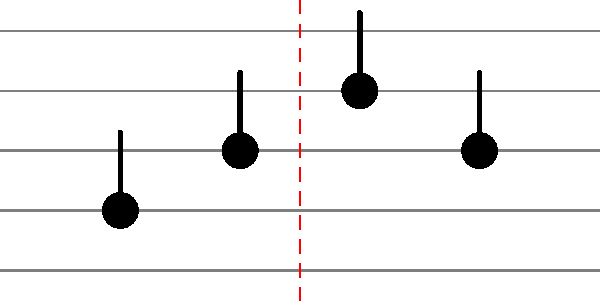In this musical notation pattern inspired by Dardust's compositions, what type of symmetry is exhibited by the arrangement of notes? To determine the type of symmetry in this musical notation pattern, let's analyze it step-by-step:

1. Observe the arrangement of notes on the staff:
   - The first note is on the second line from the bottom.
   - The second note is in the space between the second and third lines.
   - The third note is on the third line.
   - The fourth note is in the space between the second and third lines.

2. Notice the red dashed line in the middle of the staff. This line acts as a potential axis of symmetry.

3. Compare the notes on either side of the red dashed line:
   - The first and fourth notes are equidistant from the red line.
   - The second and third notes are also equidistant from the red line.

4. Imagine folding the staff along the red dashed line:
   - The first note would overlap with the fourth note.
   - The second note would overlap with the third note.

5. This pattern of reflection around a central axis is characteristic of reflection symmetry, also known as mirror symmetry or line symmetry.

6. In music theory, this type of symmetry is often used to create balanced and harmonious compositions, which is a technique Dardust frequently employs in his productions.

Therefore, the arrangement of notes in this pattern exhibits reflection symmetry around the vertical axis represented by the red dashed line.
Answer: Reflection symmetry 